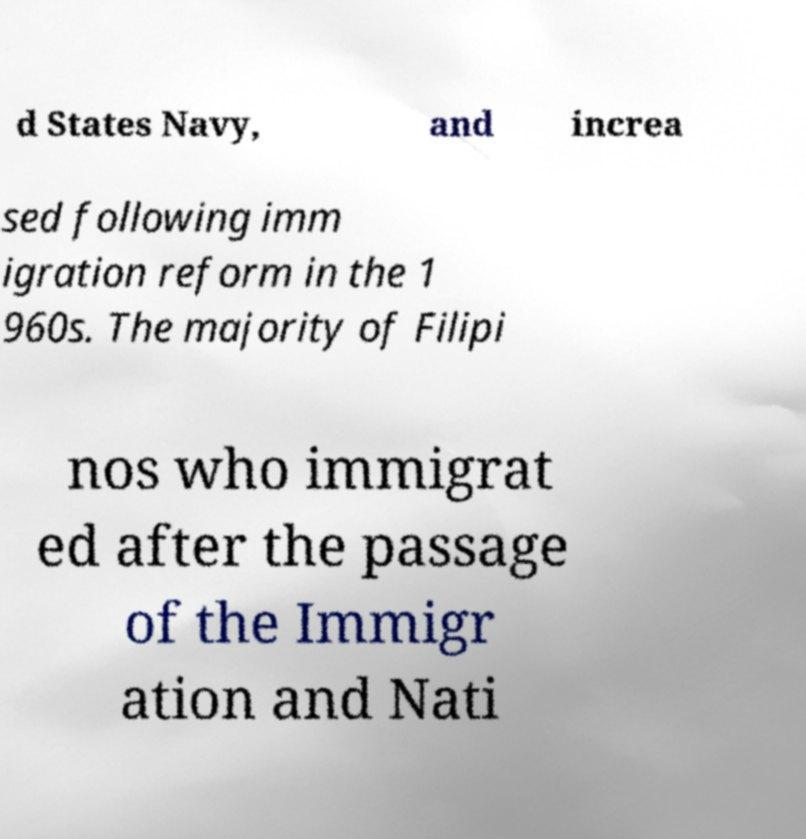Please identify and transcribe the text found in this image. d States Navy, and increa sed following imm igration reform in the 1 960s. The majority of Filipi nos who immigrat ed after the passage of the Immigr ation and Nati 